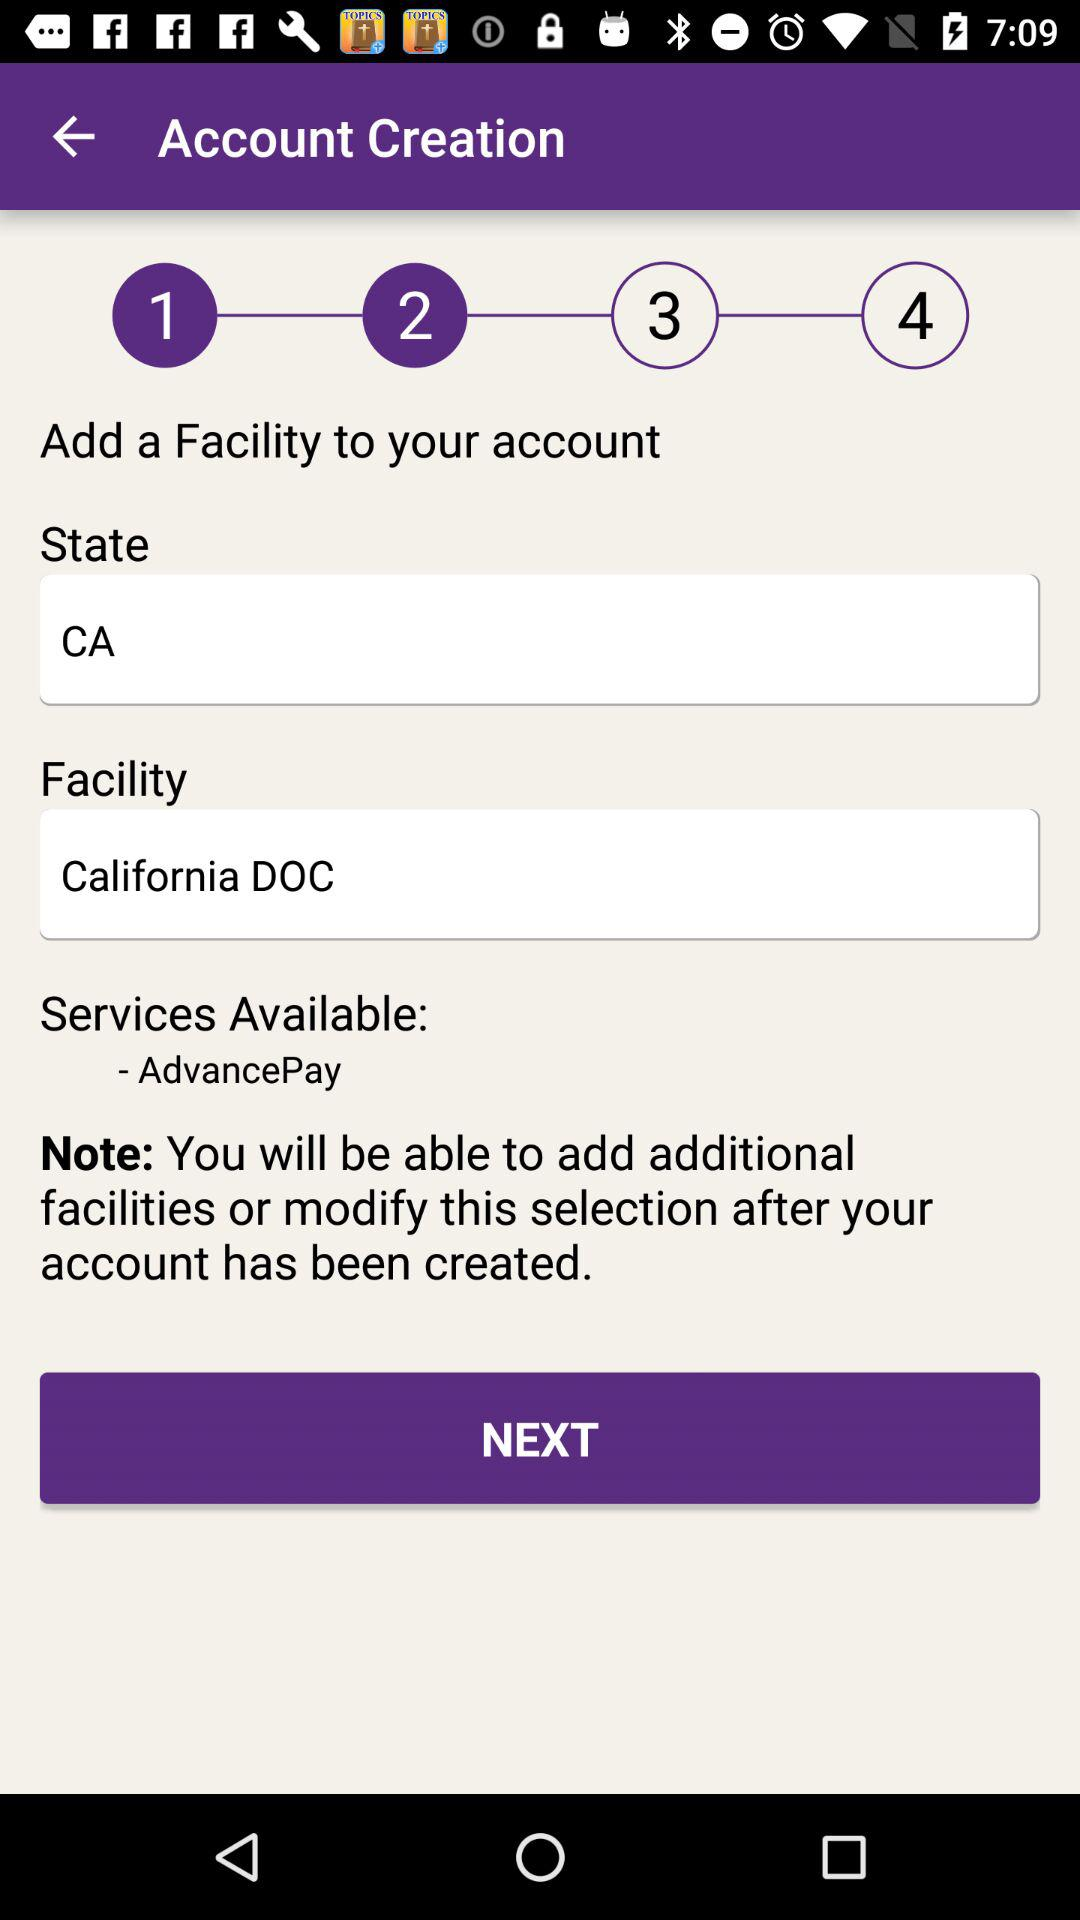How many total steps are there to complete the account creation? There are 4 steps to complete the account creation. 